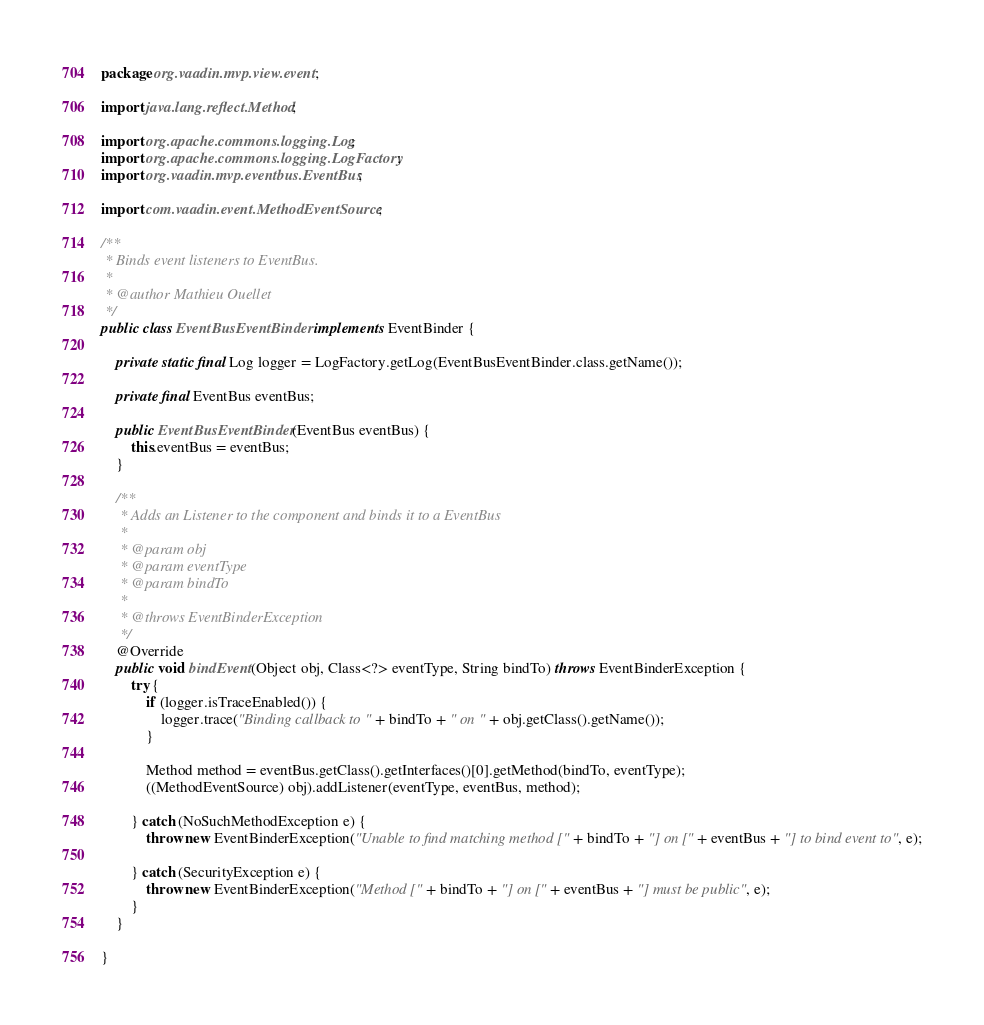<code> <loc_0><loc_0><loc_500><loc_500><_Java_>package org.vaadin.mvp.view.event;

import java.lang.reflect.Method;

import org.apache.commons.logging.Log;
import org.apache.commons.logging.LogFactory;
import org.vaadin.mvp.eventbus.EventBus;

import com.vaadin.event.MethodEventSource;

/**
 * Binds event listeners to EventBus.
 *
 * @author Mathieu Ouellet
 */
public class EventBusEventBinder implements EventBinder {

    private static final Log logger = LogFactory.getLog(EventBusEventBinder.class.getName());

    private final EventBus eventBus;

    public EventBusEventBinder(EventBus eventBus) {
        this.eventBus = eventBus;
    }

    /**
     * Adds an Listener to the component and binds it to a EventBus
     *
     * @param obj
     * @param eventType
     * @param bindTo
     *
     * @throws EventBinderException
     */
    @Override
    public void bindEvent(Object obj, Class<?> eventType, String bindTo) throws EventBinderException {
        try {
            if (logger.isTraceEnabled()) {
                logger.trace("Binding callback to " + bindTo + " on " + obj.getClass().getName());
            }

            Method method = eventBus.getClass().getInterfaces()[0].getMethod(bindTo, eventType);
            ((MethodEventSource) obj).addListener(eventType, eventBus, method);

        } catch (NoSuchMethodException e) {
            throw new EventBinderException("Unable to find matching method [" + bindTo + "] on [" + eventBus + "] to bind event to", e);

        } catch (SecurityException e) {
            throw new EventBinderException("Method [" + bindTo + "] on [" + eventBus + "] must be public", e);
        }
    }

}
</code> 